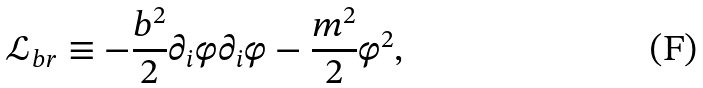Convert formula to latex. <formula><loc_0><loc_0><loc_500><loc_500>\mathcal { L } _ { b r } \equiv - \frac { b ^ { 2 } } { 2 } \partial _ { i } \varphi \partial _ { i } \varphi - \frac { m ^ { 2 } } { 2 } \varphi ^ { 2 } ,</formula> 